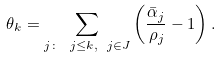<formula> <loc_0><loc_0><loc_500><loc_500>\theta _ { k } = \sum _ { j \colon \ j \leq k , \ j \in J } \left ( \frac { \bar { \alpha } _ { j } } { \rho _ { j } } - 1 \right ) .</formula> 